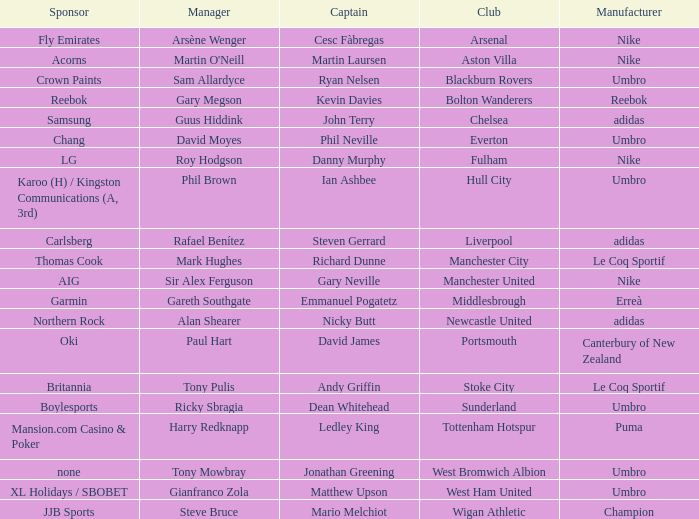Who is Dean Whitehead's manager? Ricky Sbragia. 